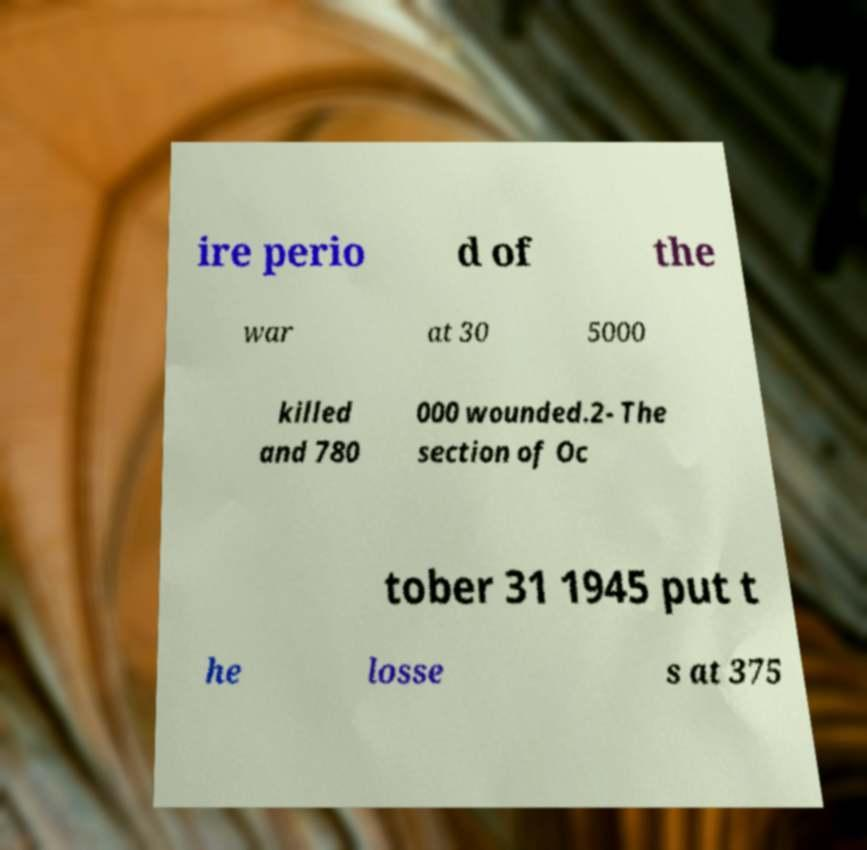I need the written content from this picture converted into text. Can you do that? ire perio d of the war at 30 5000 killed and 780 000 wounded.2- The section of Oc tober 31 1945 put t he losse s at 375 